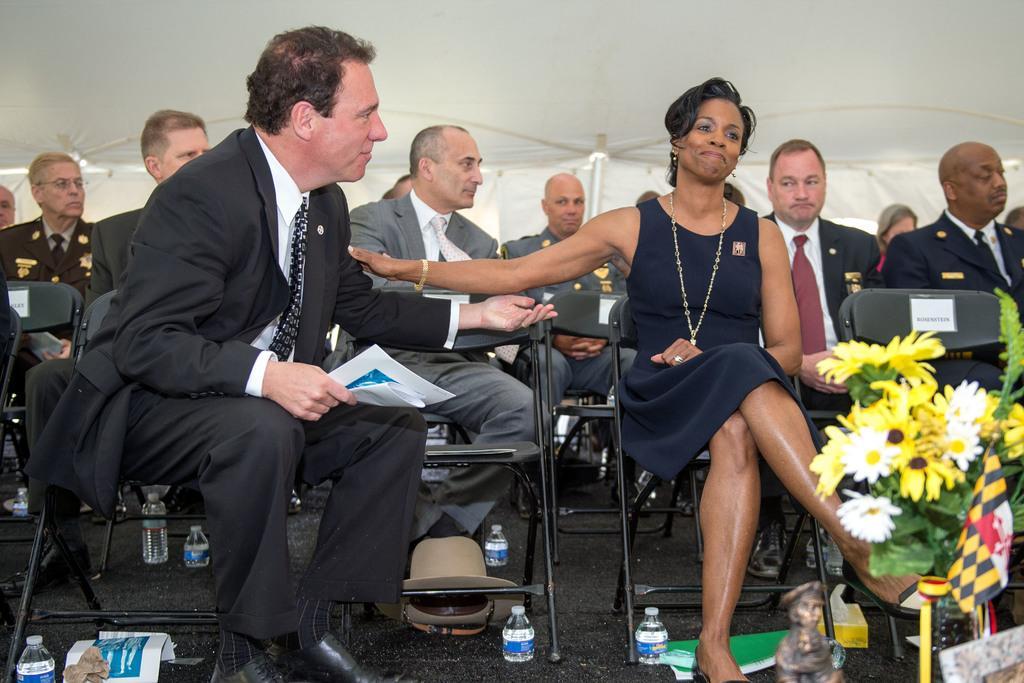In one or two sentences, can you explain what this image depicts? On the right side there is a woman sitting on a chair and smiling. On the left side there is a man sitting on a chair, holding few papers in the hand and looking at this woman. In the bottom right there are few flowers and leaves. At the bottom there are many bottles placed on the floor and also there are few papers. In the background few men are sitting on the chairs. At the top of the image there is a white color tint. 